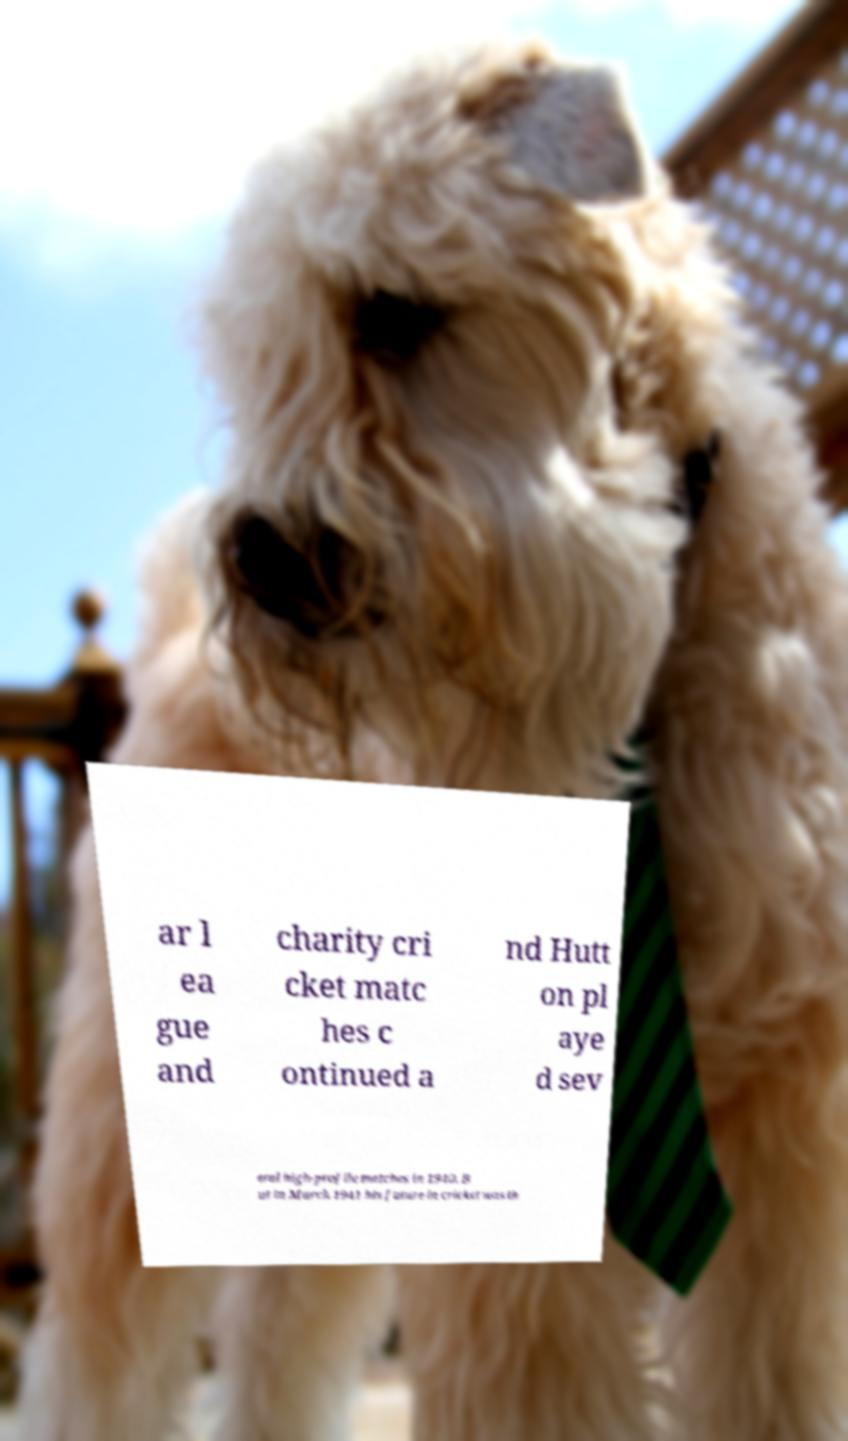Please read and relay the text visible in this image. What does it say? ar l ea gue and charity cri cket matc hes c ontinued a nd Hutt on pl aye d sev eral high-profile matches in 1940. B ut in March 1941 his future in cricket was th 